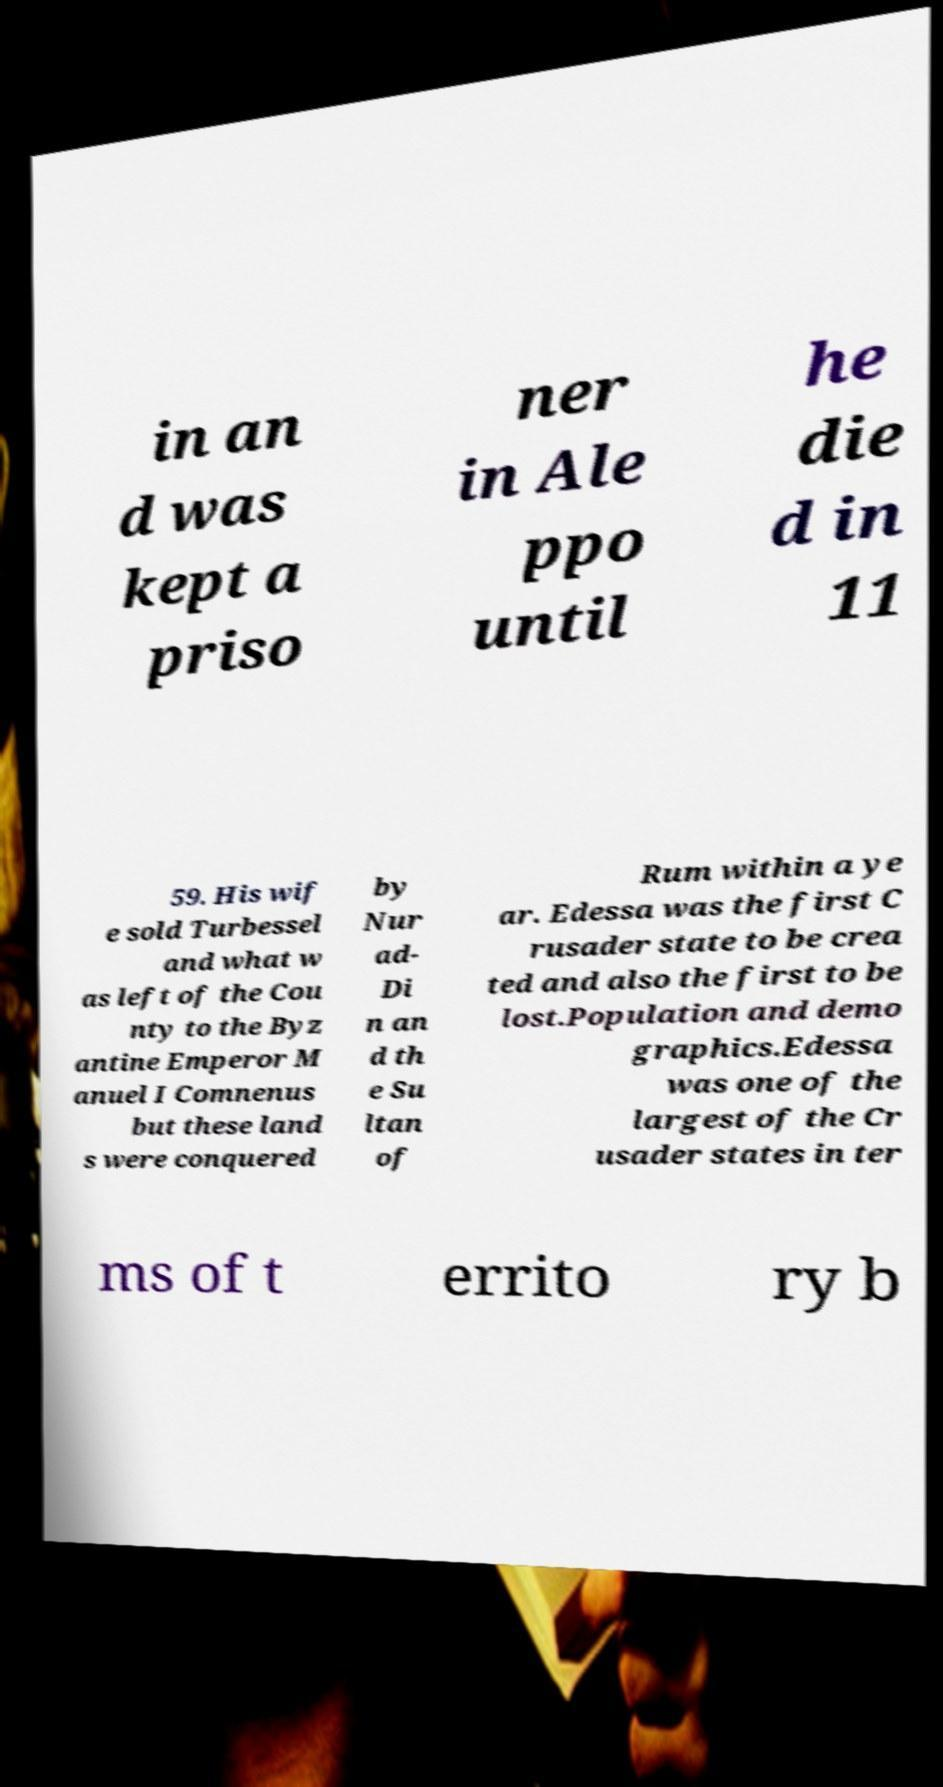Could you assist in decoding the text presented in this image and type it out clearly? in an d was kept a priso ner in Ale ppo until he die d in 11 59. His wif e sold Turbessel and what w as left of the Cou nty to the Byz antine Emperor M anuel I Comnenus but these land s were conquered by Nur ad- Di n an d th e Su ltan of Rum within a ye ar. Edessa was the first C rusader state to be crea ted and also the first to be lost.Population and demo graphics.Edessa was one of the largest of the Cr usader states in ter ms of t errito ry b 